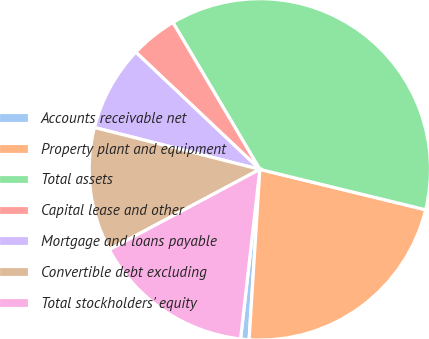<chart> <loc_0><loc_0><loc_500><loc_500><pie_chart><fcel>Accounts receivable net<fcel>Property plant and equipment<fcel>Total assets<fcel>Capital lease and other<fcel>Mortgage and loans payable<fcel>Convertible debt excluding<fcel>Total stockholders' equity<nl><fcel>0.8%<fcel>22.2%<fcel>37.31%<fcel>4.45%<fcel>8.1%<fcel>11.75%<fcel>15.4%<nl></chart> 